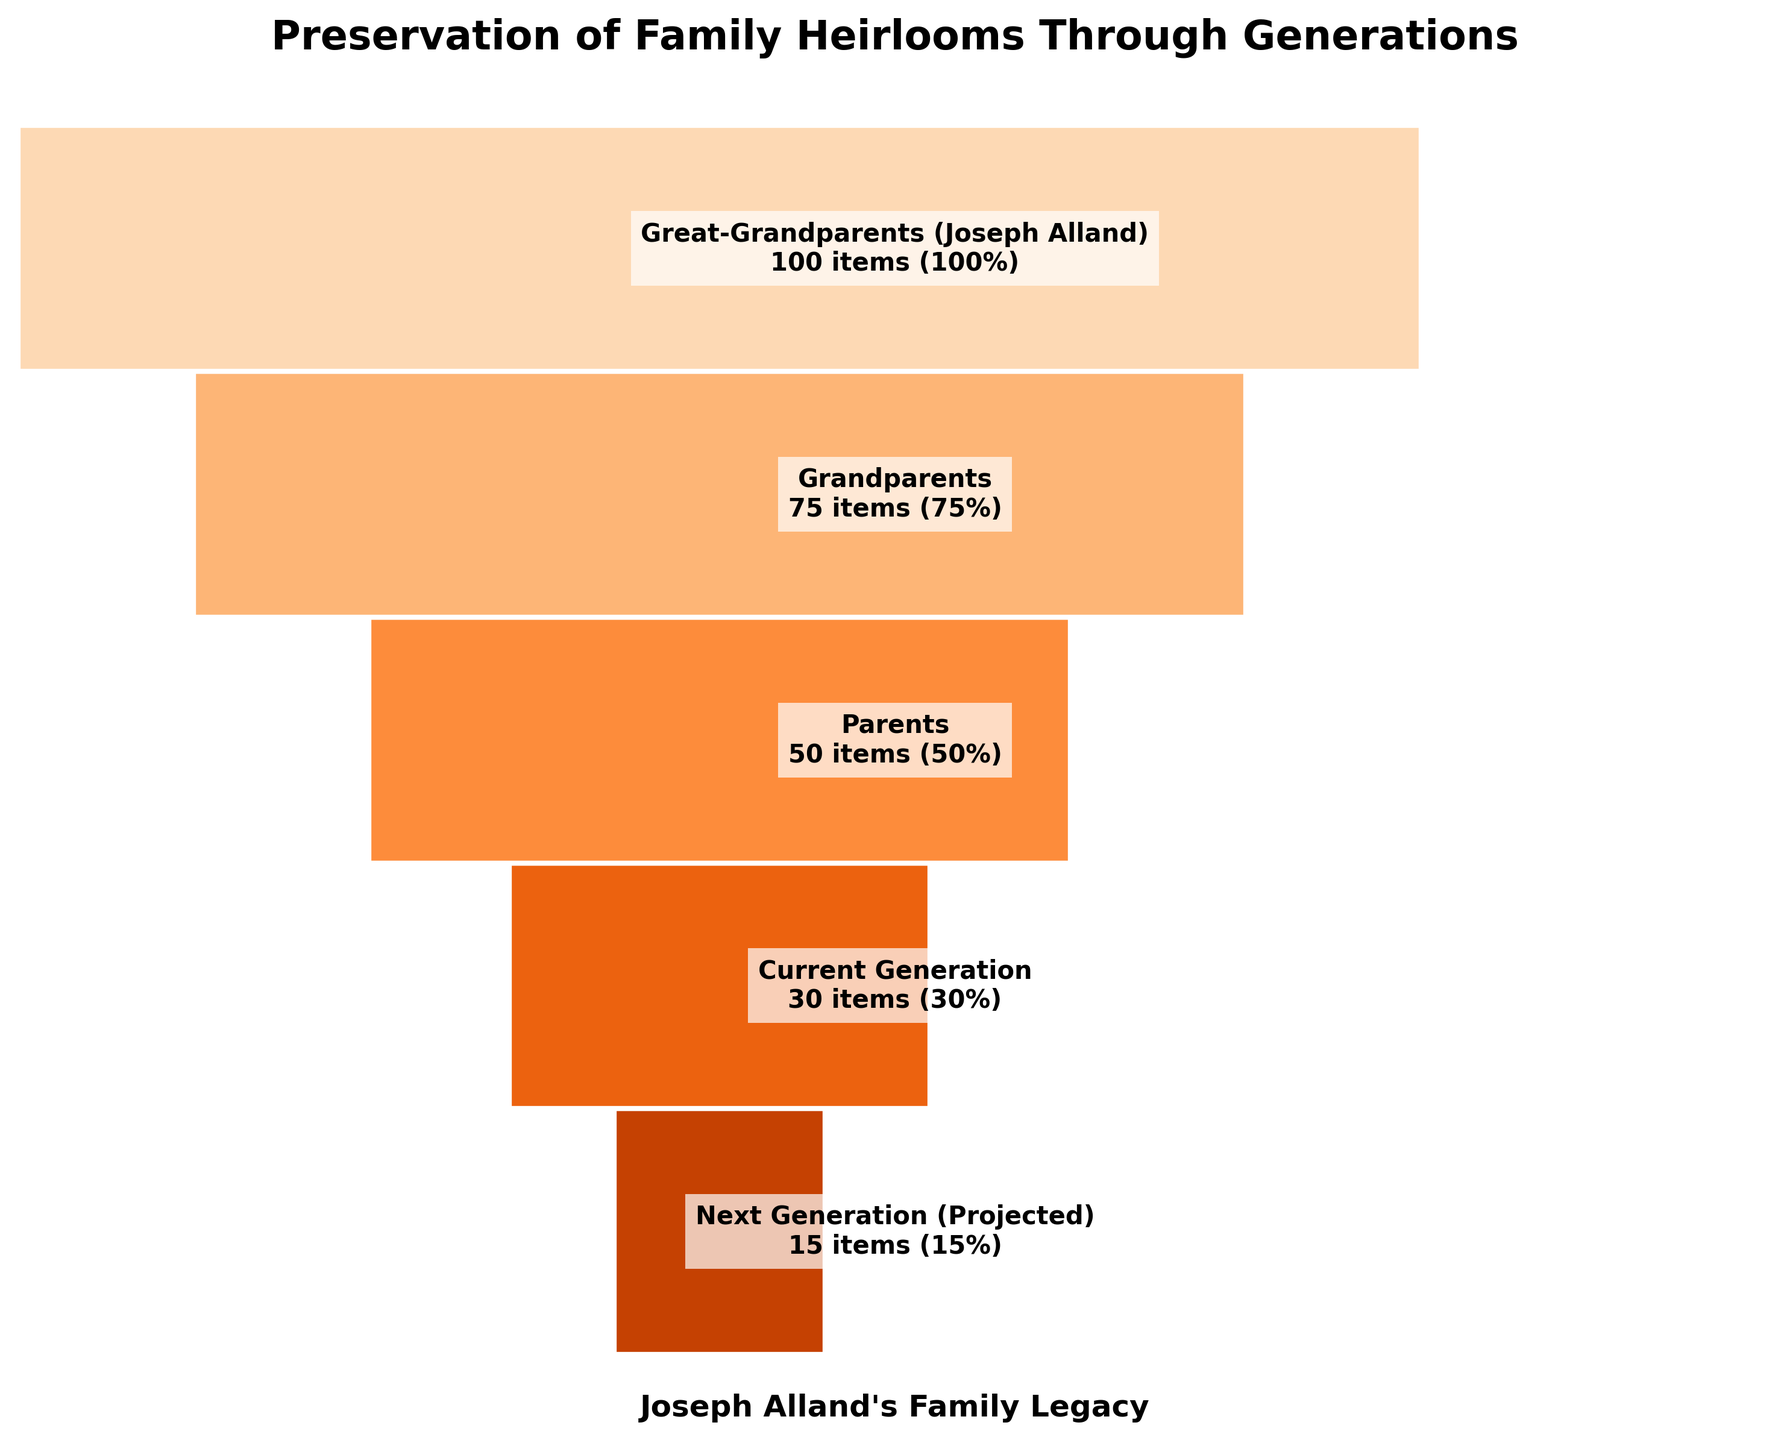what is the title of the figure? The title is clearly displayed at the top of the figure in bold and larger font size.
Answer: Preservation of Family Heirlooms Through Generations Which generation preserved the highest number of items? The figure shows trapezoids for each generation, labeled with the number of items preserved. The largest trapezoid with the highest number is for Great-Grandparents.
Answer: Great-Grandparents (Joseph Alland) How many items does the current generation preserve compared to parents? Read the number of items preserved from both generations: 30 items for the current generation and 50 items for parents. The difference can be found by subtracting 30 from 50.
Answer: 20 fewer items What is the overall trend in the number of items preserved from Great-Grandparents to the projected next generation? The trapezoids decrease in size from top to bottom, reflecting a downward trend in the number of items preserved.
Answer: Decreasing Which generation has the largest drop in the percentage of items preserved compared to the previous generation? Calculate the percentage drops between consecutive generations. The largest drop is from the parents (50%) to the current generation (30%), a difference of 20%.
Answer: From Parents to Current Generation On average, by what percentage do items decrease from one generation to the next? Calculate the average percentage decrease: [(100-75) + (75-50) + (50-30) + (30-15)] / 4 = 20%.
Answer: 20% Which generation is projected to have the smallest number of preserved items? The figure shows the descending trend of items per generation; the smallest value seen at the bottom is for the next projected generation.
Answer: Next Generation What color scheme is used in the figure? The figure uses shades of a single color; the progression from light to dark can be identified. In this case, the color used is shades of orange.
Answer: Shades of orange How many generations are represented in the figure? Count the number of trapezoids or generation labels presented from top to bottom.
Answer: Five generations What is the percentage of items preserved by the generation before Joseph Alland's great-grandchild? Referring to the parent's generation, the percentage is inscribed within the parental trapezoid as 50%.
Answer: 50% 